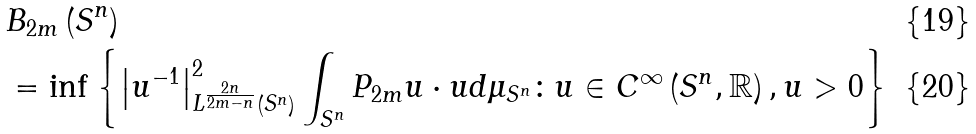<formula> <loc_0><loc_0><loc_500><loc_500>& B _ { 2 m } \left ( S ^ { n } \right ) \\ & = \inf \left \{ \left | u ^ { - 1 } \right | _ { L ^ { \frac { 2 n } { 2 m - n } } \left ( S ^ { n } \right ) } ^ { 2 } \int _ { S ^ { n } } P _ { 2 m } u \cdot u d \mu _ { S ^ { n } } \colon u \in C ^ { \infty } \left ( S ^ { n } , \mathbb { R } \right ) , u > 0 \right \}</formula> 